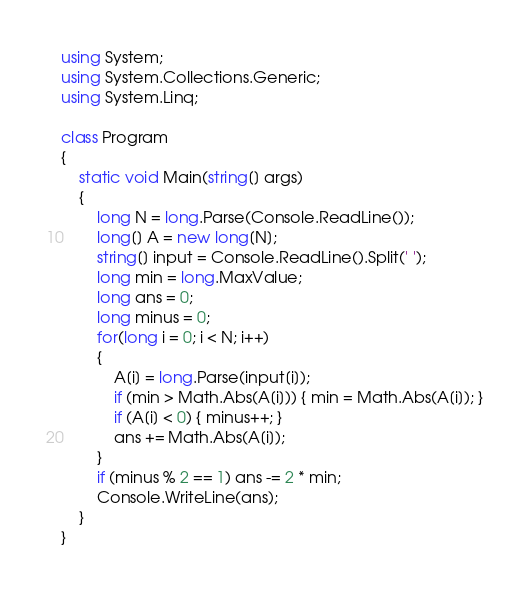<code> <loc_0><loc_0><loc_500><loc_500><_C#_>using System;
using System.Collections.Generic;
using System.Linq;

class Program
{
    static void Main(string[] args)
    {
        long N = long.Parse(Console.ReadLine());
        long[] A = new long[N];
        string[] input = Console.ReadLine().Split(' ');
        long min = long.MaxValue;
        long ans = 0;
        long minus = 0;
        for(long i = 0; i < N; i++)
        {
            A[i] = long.Parse(input[i]);
            if (min > Math.Abs(A[i])) { min = Math.Abs(A[i]); }
            if (A[i] < 0) { minus++; }
            ans += Math.Abs(A[i]);
        }
        if (minus % 2 == 1) ans -= 2 * min;
        Console.WriteLine(ans);
    }
}</code> 